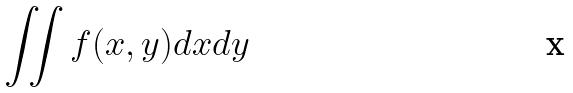Convert formula to latex. <formula><loc_0><loc_0><loc_500><loc_500>\iint f ( x , y ) d x d y</formula> 